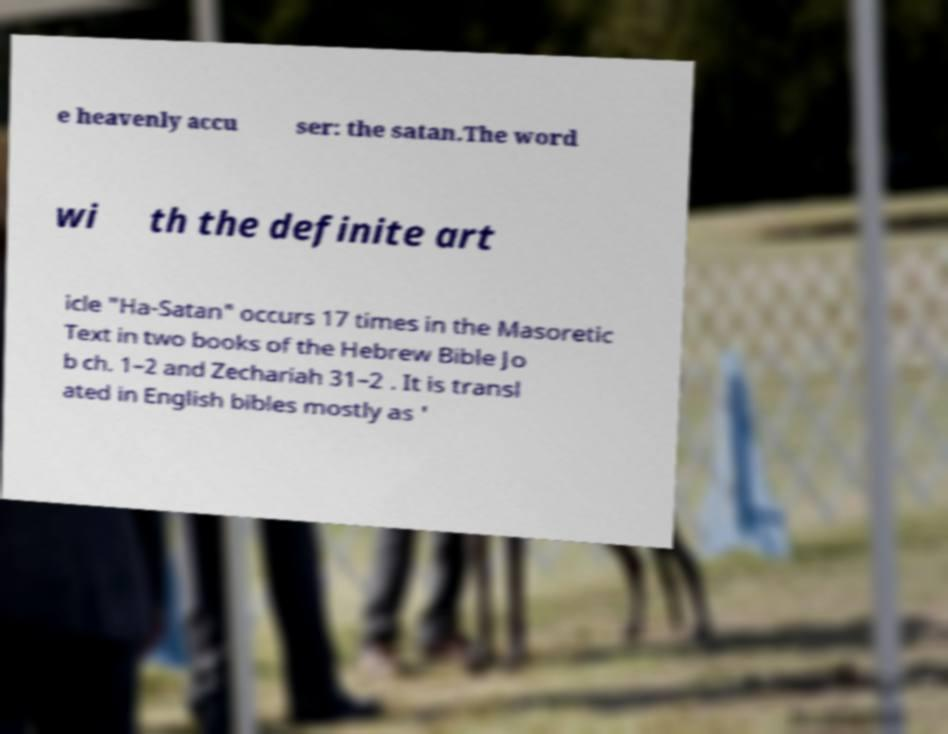Please identify and transcribe the text found in this image. e heavenly accu ser: the satan.The word wi th the definite art icle "Ha-Satan" occurs 17 times in the Masoretic Text in two books of the Hebrew Bible Jo b ch. 1–2 and Zechariah 31–2 . It is transl ated in English bibles mostly as ' 